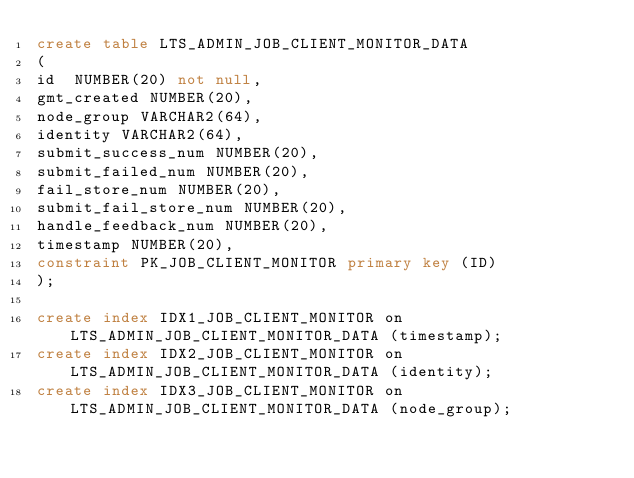Convert code to text. <code><loc_0><loc_0><loc_500><loc_500><_SQL_>create table LTS_ADMIN_JOB_CLIENT_MONITOR_DATA
(
id  NUMBER(20) not null,
gmt_created NUMBER(20),
node_group VARCHAR2(64),
identity VARCHAR2(64),
submit_success_num NUMBER(20),
submit_failed_num NUMBER(20),
fail_store_num NUMBER(20),
submit_fail_store_num NUMBER(20),
handle_feedback_num NUMBER(20),
timestamp NUMBER(20),
constraint PK_JOB_CLIENT_MONITOR primary key (ID)
);

create index IDX1_JOB_CLIENT_MONITOR on LTS_ADMIN_JOB_CLIENT_MONITOR_DATA (timestamp);
create index IDX2_JOB_CLIENT_MONITOR on LTS_ADMIN_JOB_CLIENT_MONITOR_DATA (identity);
create index IDX3_JOB_CLIENT_MONITOR on LTS_ADMIN_JOB_CLIENT_MONITOR_DATA (node_group);</code> 